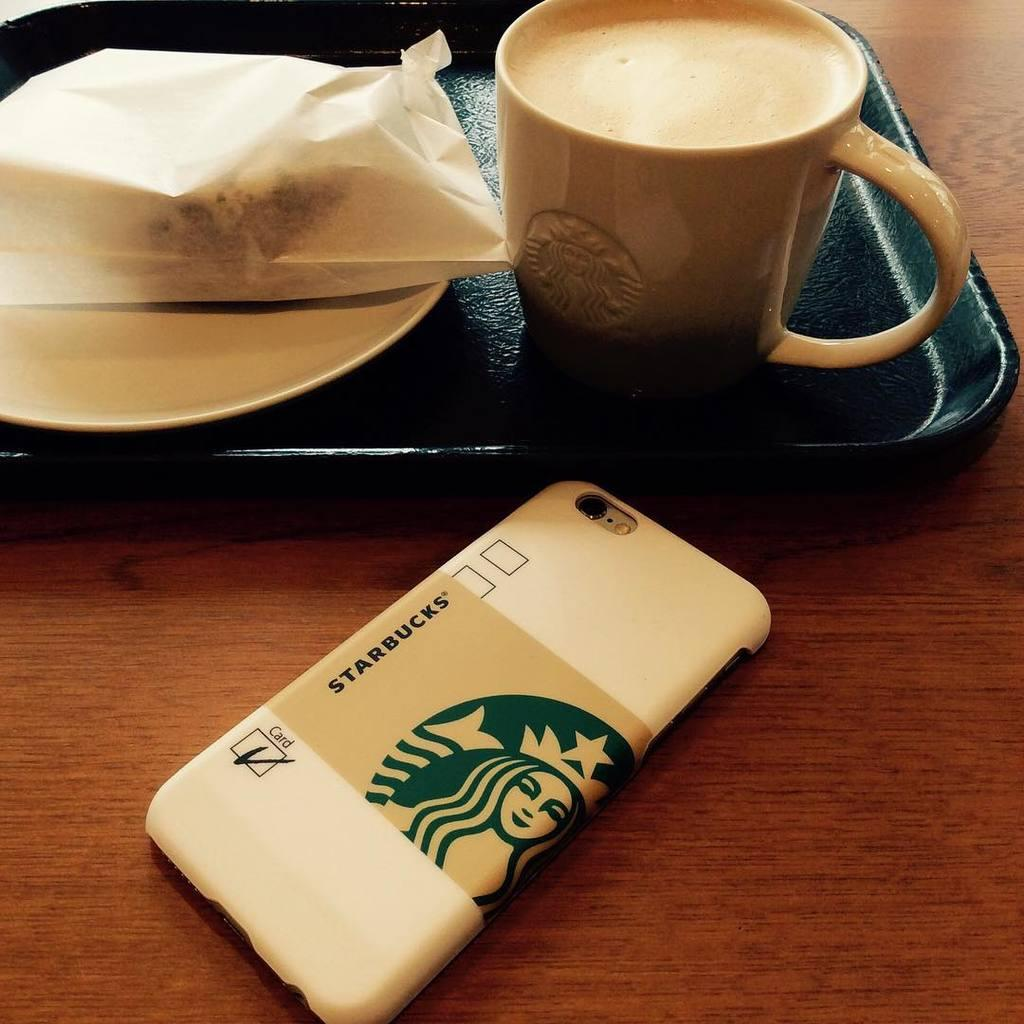<image>
Relay a brief, clear account of the picture shown. A phone with a Starbucks wrapper is next to a tray with coffee and a wrapped pastry. 